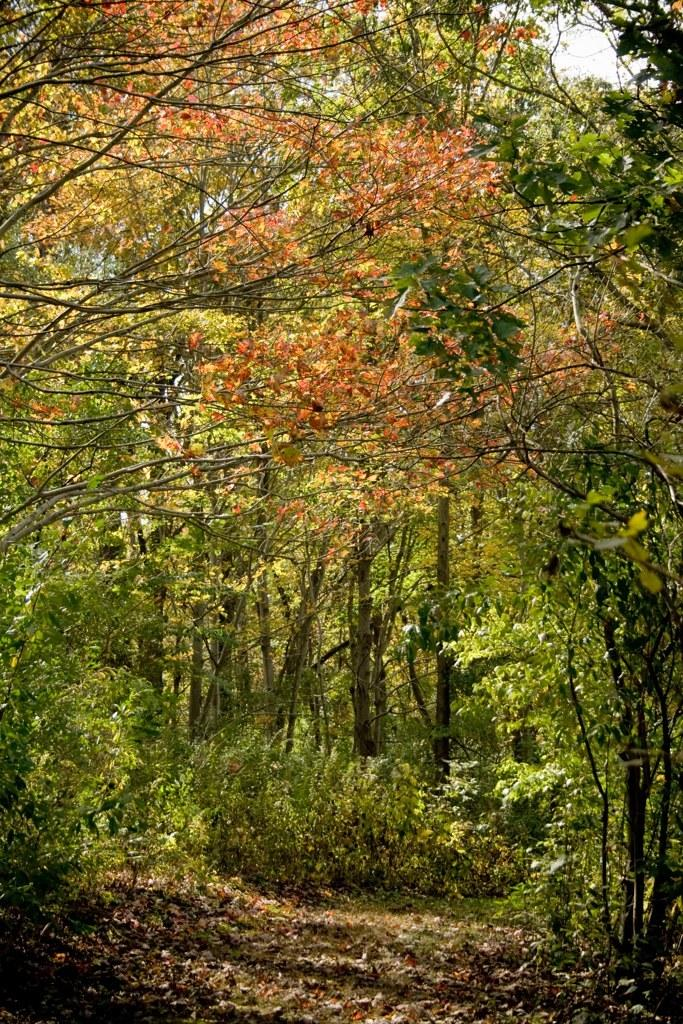What type of vegetation can be seen in the image? There are many trees and plants in the image. What is present at the bottom of the image? Dry leaves and grass are visible at the bottom of the image. What can be seen in the background of the image? The sky is visible in the background of the image. What type of screw can be seen in the image? There is no screw present in the image. Is there a glove visible in the image? No, there is no glove present in the image. 